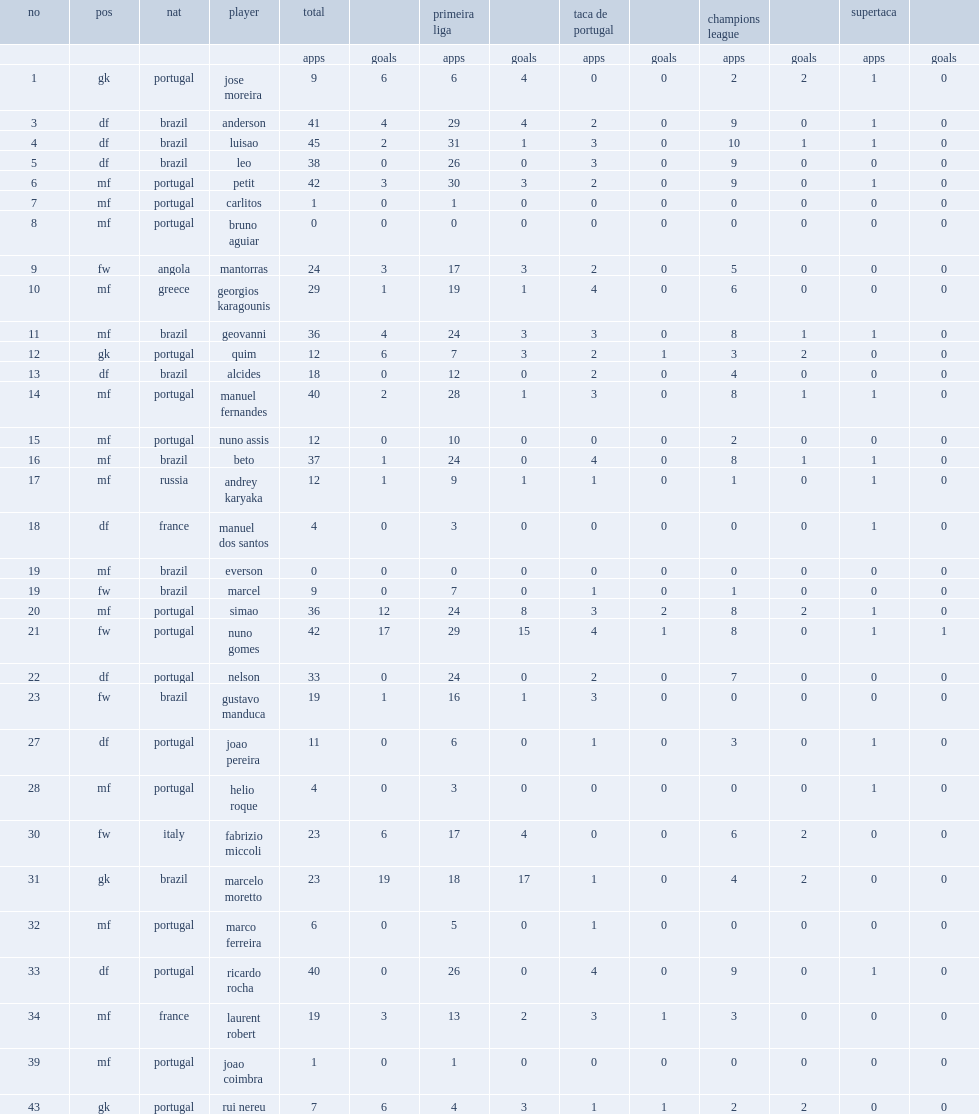What the matches did benfica compete in the 2005-06 season? Primeira liga taca de portugal champions league. 